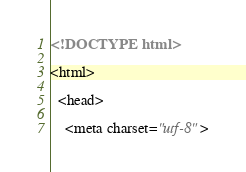Convert code to text. <code><loc_0><loc_0><loc_500><loc_500><_HTML_><!DOCTYPE html>

<html>

  <head>

    <meta charset="utf-8"></code> 